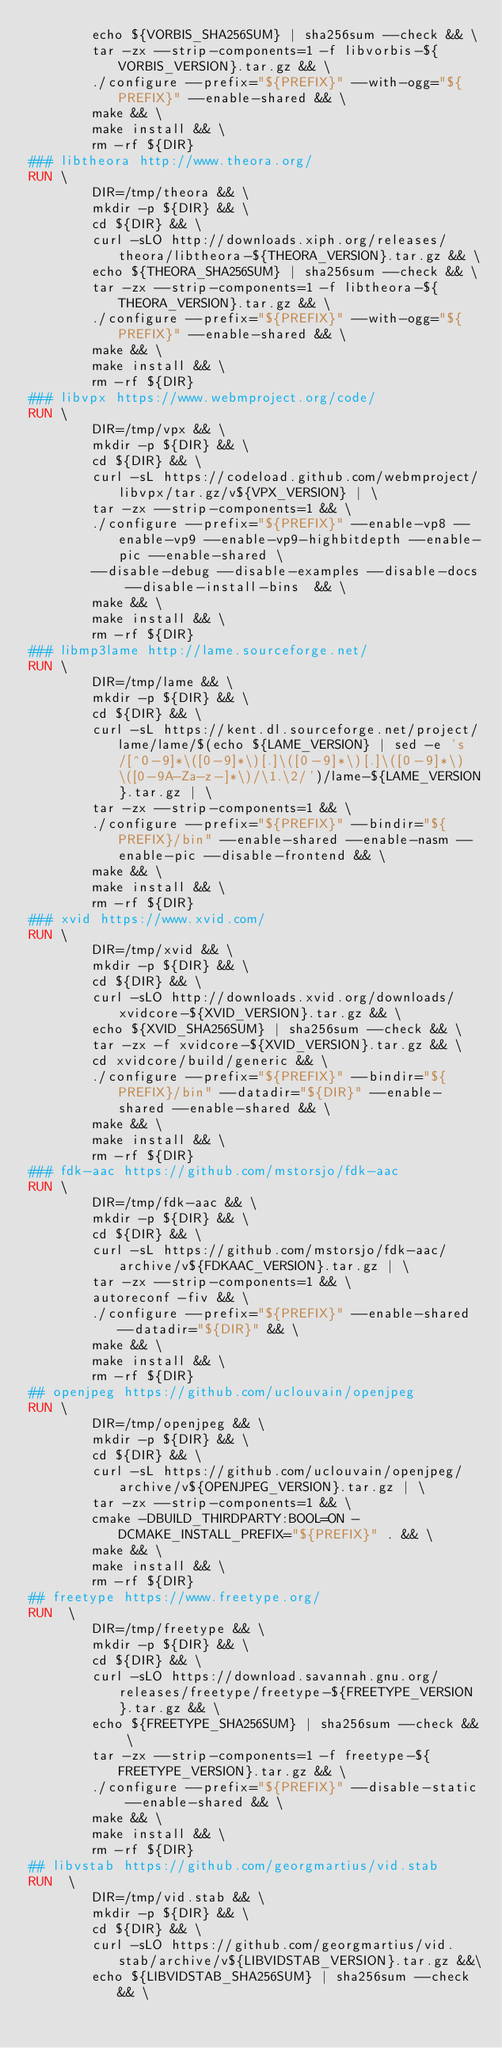<code> <loc_0><loc_0><loc_500><loc_500><_Dockerfile_>        echo ${VORBIS_SHA256SUM} | sha256sum --check && \
        tar -zx --strip-components=1 -f libvorbis-${VORBIS_VERSION}.tar.gz && \
        ./configure --prefix="${PREFIX}" --with-ogg="${PREFIX}" --enable-shared && \
        make && \
        make install && \
        rm -rf ${DIR}
### libtheora http://www.theora.org/
RUN \
        DIR=/tmp/theora && \
        mkdir -p ${DIR} && \
        cd ${DIR} && \
        curl -sLO http://downloads.xiph.org/releases/theora/libtheora-${THEORA_VERSION}.tar.gz && \
        echo ${THEORA_SHA256SUM} | sha256sum --check && \
        tar -zx --strip-components=1 -f libtheora-${THEORA_VERSION}.tar.gz && \
        ./configure --prefix="${PREFIX}" --with-ogg="${PREFIX}" --enable-shared && \
        make && \
        make install && \
        rm -rf ${DIR}
### libvpx https://www.webmproject.org/code/
RUN \
        DIR=/tmp/vpx && \
        mkdir -p ${DIR} && \
        cd ${DIR} && \
        curl -sL https://codeload.github.com/webmproject/libvpx/tar.gz/v${VPX_VERSION} | \
        tar -zx --strip-components=1 && \
        ./configure --prefix="${PREFIX}" --enable-vp8 --enable-vp9 --enable-vp9-highbitdepth --enable-pic --enable-shared \
        --disable-debug --disable-examples --disable-docs --disable-install-bins  && \
        make && \
        make install && \
        rm -rf ${DIR}
### libmp3lame http://lame.sourceforge.net/
RUN \
        DIR=/tmp/lame && \
        mkdir -p ${DIR} && \
        cd ${DIR} && \
        curl -sL https://kent.dl.sourceforge.net/project/lame/lame/$(echo ${LAME_VERSION} | sed -e 's/[^0-9]*\([0-9]*\)[.]\([0-9]*\)[.]\([0-9]*\)\([0-9A-Za-z-]*\)/\1.\2/')/lame-${LAME_VERSION}.tar.gz | \
        tar -zx --strip-components=1 && \
        ./configure --prefix="${PREFIX}" --bindir="${PREFIX}/bin" --enable-shared --enable-nasm --enable-pic --disable-frontend && \
        make && \
        make install && \
        rm -rf ${DIR}
### xvid https://www.xvid.com/
RUN \
        DIR=/tmp/xvid && \
        mkdir -p ${DIR} && \
        cd ${DIR} && \
        curl -sLO http://downloads.xvid.org/downloads/xvidcore-${XVID_VERSION}.tar.gz && \
        echo ${XVID_SHA256SUM} | sha256sum --check && \
        tar -zx -f xvidcore-${XVID_VERSION}.tar.gz && \
        cd xvidcore/build/generic && \
        ./configure --prefix="${PREFIX}" --bindir="${PREFIX}/bin" --datadir="${DIR}" --enable-shared --enable-shared && \
        make && \
        make install && \
        rm -rf ${DIR}
### fdk-aac https://github.com/mstorsjo/fdk-aac
RUN \
        DIR=/tmp/fdk-aac && \
        mkdir -p ${DIR} && \
        cd ${DIR} && \
        curl -sL https://github.com/mstorsjo/fdk-aac/archive/v${FDKAAC_VERSION}.tar.gz | \
        tar -zx --strip-components=1 && \
        autoreconf -fiv && \
        ./configure --prefix="${PREFIX}" --enable-shared --datadir="${DIR}" && \
        make && \
        make install && \
        rm -rf ${DIR}
## openjpeg https://github.com/uclouvain/openjpeg
RUN \
        DIR=/tmp/openjpeg && \
        mkdir -p ${DIR} && \
        cd ${DIR} && \
        curl -sL https://github.com/uclouvain/openjpeg/archive/v${OPENJPEG_VERSION}.tar.gz | \
        tar -zx --strip-components=1 && \
        cmake -DBUILD_THIRDPARTY:BOOL=ON -DCMAKE_INSTALL_PREFIX="${PREFIX}" . && \
        make && \
        make install && \
        rm -rf ${DIR}
## freetype https://www.freetype.org/
RUN  \
        DIR=/tmp/freetype && \
        mkdir -p ${DIR} && \
        cd ${DIR} && \
        curl -sLO https://download.savannah.gnu.org/releases/freetype/freetype-${FREETYPE_VERSION}.tar.gz && \
        echo ${FREETYPE_SHA256SUM} | sha256sum --check && \
        tar -zx --strip-components=1 -f freetype-${FREETYPE_VERSION}.tar.gz && \
        ./configure --prefix="${PREFIX}" --disable-static --enable-shared && \
        make && \
        make install && \
        rm -rf ${DIR}
## libvstab https://github.com/georgmartius/vid.stab
RUN  \
        DIR=/tmp/vid.stab && \
        mkdir -p ${DIR} && \
        cd ${DIR} && \
        curl -sLO https://github.com/georgmartius/vid.stab/archive/v${LIBVIDSTAB_VERSION}.tar.gz &&\
        echo ${LIBVIDSTAB_SHA256SUM} | sha256sum --check && \</code> 